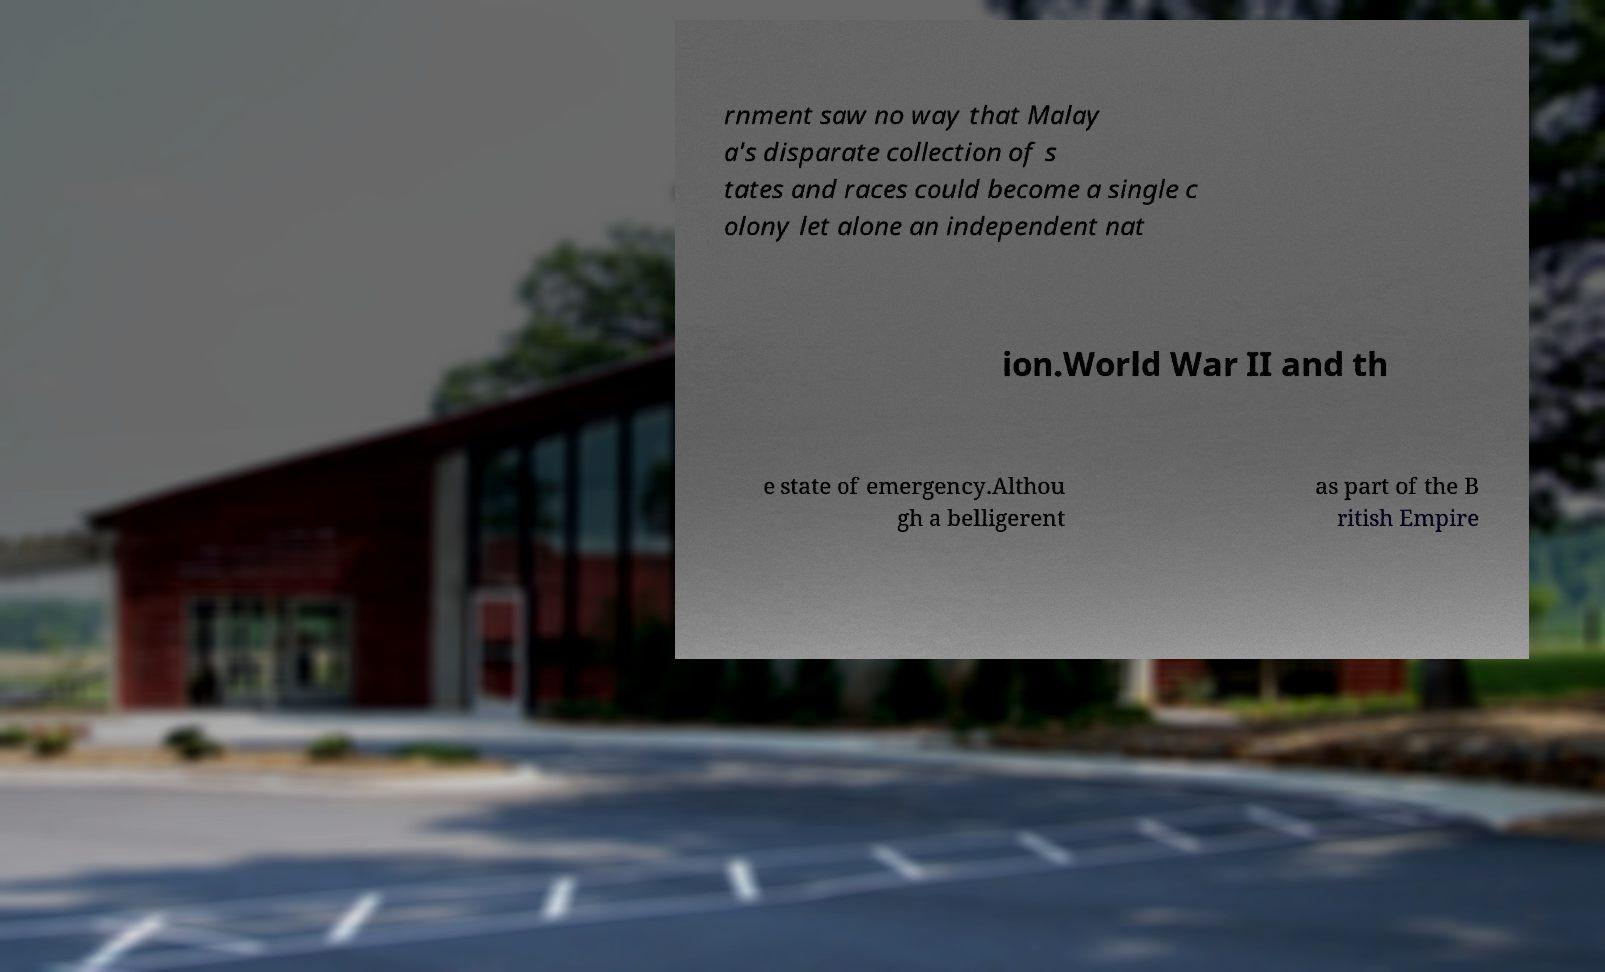Could you assist in decoding the text presented in this image and type it out clearly? rnment saw no way that Malay a's disparate collection of s tates and races could become a single c olony let alone an independent nat ion.World War II and th e state of emergency.Althou gh a belligerent as part of the B ritish Empire 